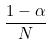Convert formula to latex. <formula><loc_0><loc_0><loc_500><loc_500>\frac { 1 - \alpha } { N }</formula> 